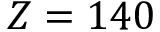<formula> <loc_0><loc_0><loc_500><loc_500>Z = 1 4 0</formula> 